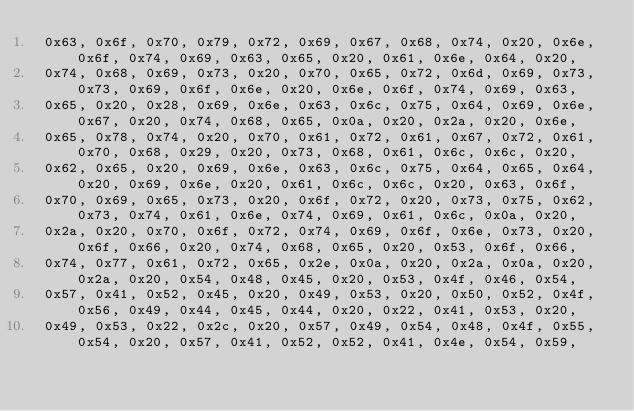Convert code to text. <code><loc_0><loc_0><loc_500><loc_500><_C_> 0x63, 0x6f, 0x70, 0x79, 0x72, 0x69, 0x67, 0x68, 0x74, 0x20, 0x6e, 0x6f, 0x74, 0x69, 0x63, 0x65, 0x20, 0x61, 0x6e, 0x64, 0x20, 
 0x74, 0x68, 0x69, 0x73, 0x20, 0x70, 0x65, 0x72, 0x6d, 0x69, 0x73, 0x73, 0x69, 0x6f, 0x6e, 0x20, 0x6e, 0x6f, 0x74, 0x69, 0x63, 
 0x65, 0x20, 0x28, 0x69, 0x6e, 0x63, 0x6c, 0x75, 0x64, 0x69, 0x6e, 0x67, 0x20, 0x74, 0x68, 0x65, 0x0a, 0x20, 0x2a, 0x20, 0x6e, 
 0x65, 0x78, 0x74, 0x20, 0x70, 0x61, 0x72, 0x61, 0x67, 0x72, 0x61, 0x70, 0x68, 0x29, 0x20, 0x73, 0x68, 0x61, 0x6c, 0x6c, 0x20, 
 0x62, 0x65, 0x20, 0x69, 0x6e, 0x63, 0x6c, 0x75, 0x64, 0x65, 0x64, 0x20, 0x69, 0x6e, 0x20, 0x61, 0x6c, 0x6c, 0x20, 0x63, 0x6f, 
 0x70, 0x69, 0x65, 0x73, 0x20, 0x6f, 0x72, 0x20, 0x73, 0x75, 0x62, 0x73, 0x74, 0x61, 0x6e, 0x74, 0x69, 0x61, 0x6c, 0x0a, 0x20, 
 0x2a, 0x20, 0x70, 0x6f, 0x72, 0x74, 0x69, 0x6f, 0x6e, 0x73, 0x20, 0x6f, 0x66, 0x20, 0x74, 0x68, 0x65, 0x20, 0x53, 0x6f, 0x66, 
 0x74, 0x77, 0x61, 0x72, 0x65, 0x2e, 0x0a, 0x20, 0x2a, 0x0a, 0x20, 0x2a, 0x20, 0x54, 0x48, 0x45, 0x20, 0x53, 0x4f, 0x46, 0x54, 
 0x57, 0x41, 0x52, 0x45, 0x20, 0x49, 0x53, 0x20, 0x50, 0x52, 0x4f, 0x56, 0x49, 0x44, 0x45, 0x44, 0x20, 0x22, 0x41, 0x53, 0x20, 
 0x49, 0x53, 0x22, 0x2c, 0x20, 0x57, 0x49, 0x54, 0x48, 0x4f, 0x55, 0x54, 0x20, 0x57, 0x41, 0x52, 0x52, 0x41, 0x4e, 0x54, 0x59, </code> 